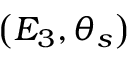<formula> <loc_0><loc_0><loc_500><loc_500>\left ( E _ { 3 } , \theta _ { s } \right )</formula> 